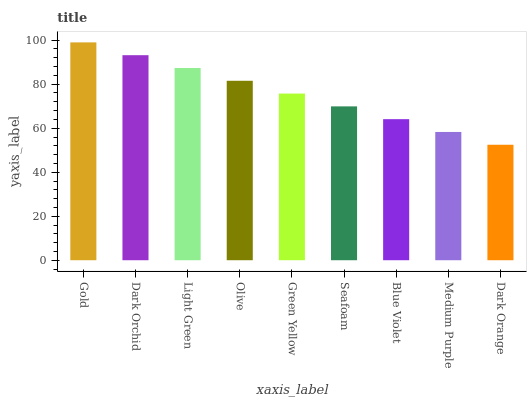Is Dark Orange the minimum?
Answer yes or no. Yes. Is Gold the maximum?
Answer yes or no. Yes. Is Dark Orchid the minimum?
Answer yes or no. No. Is Dark Orchid the maximum?
Answer yes or no. No. Is Gold greater than Dark Orchid?
Answer yes or no. Yes. Is Dark Orchid less than Gold?
Answer yes or no. Yes. Is Dark Orchid greater than Gold?
Answer yes or no. No. Is Gold less than Dark Orchid?
Answer yes or no. No. Is Green Yellow the high median?
Answer yes or no. Yes. Is Green Yellow the low median?
Answer yes or no. Yes. Is Dark Orchid the high median?
Answer yes or no. No. Is Gold the low median?
Answer yes or no. No. 